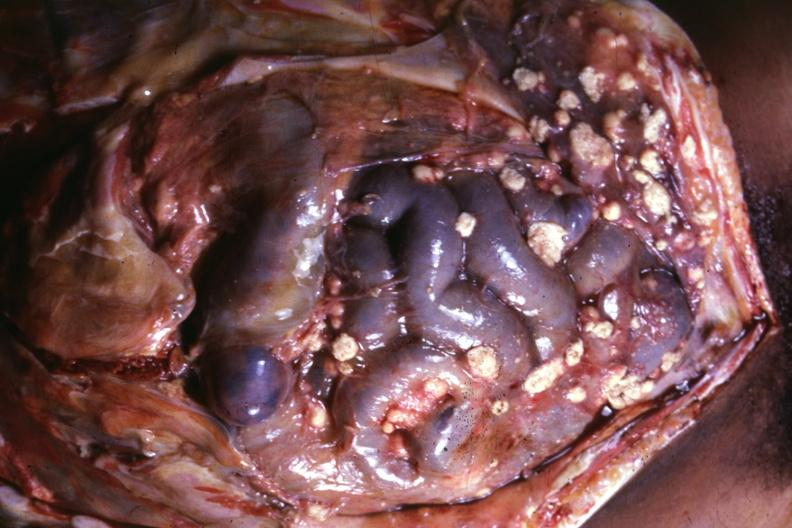s peritoneum present?
Answer the question using a single word or phrase. No 